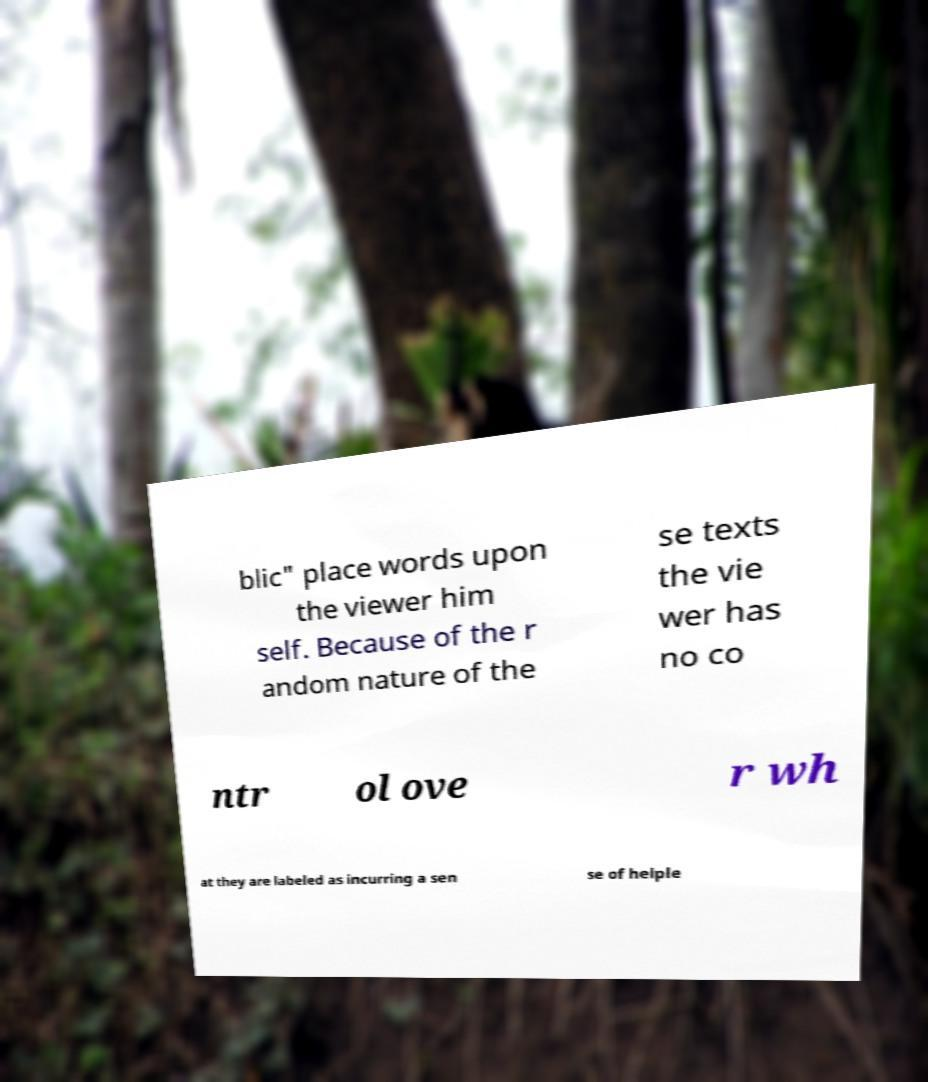Can you accurately transcribe the text from the provided image for me? blic" place words upon the viewer him self. Because of the r andom nature of the se texts the vie wer has no co ntr ol ove r wh at they are labeled as incurring a sen se of helple 